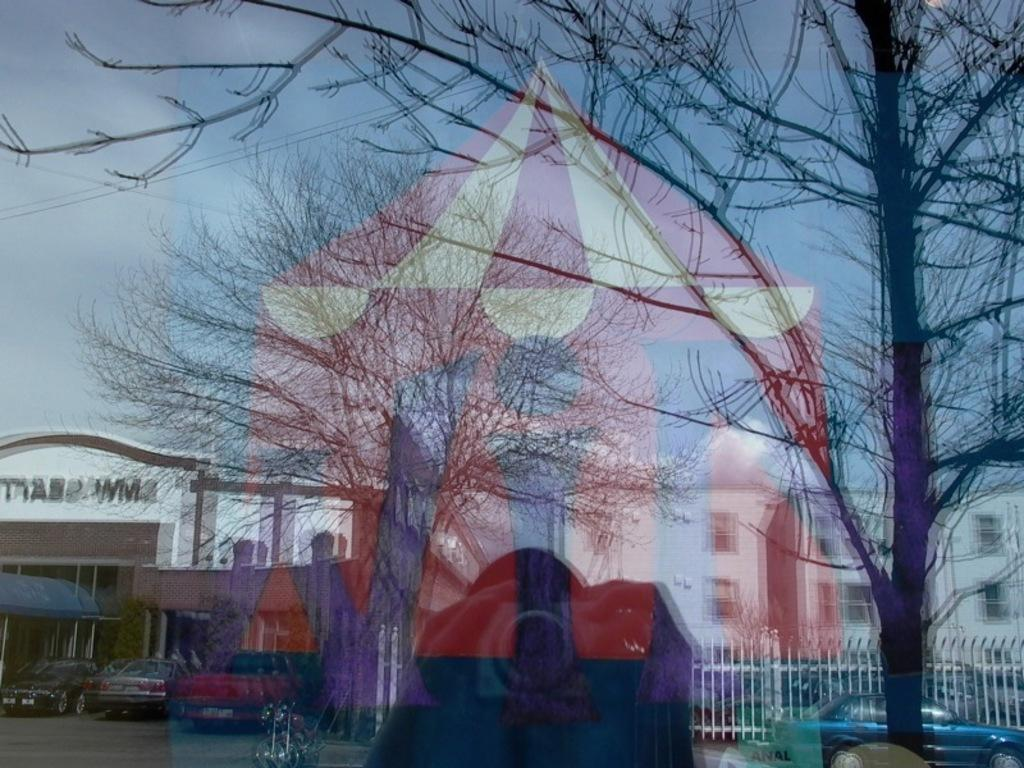What is located in the foreground of the image? There is a glass door in the foreground of the image. What can be seen through the glass door? Poles are visible through the glass door. Who is present in the scene? There is a person holding a camera in the scene. What type of vegetation is present in the scene? Trees are present in the scene. What architectural feature can be seen in the image? There is a railing visible in the image. What is visible in the background of the image? The sky is visible in the image. What type of suit is the glass wearing in the image? There is no glass wearing a suit in the image, as glass is an inanimate object and does not wear clothing. 